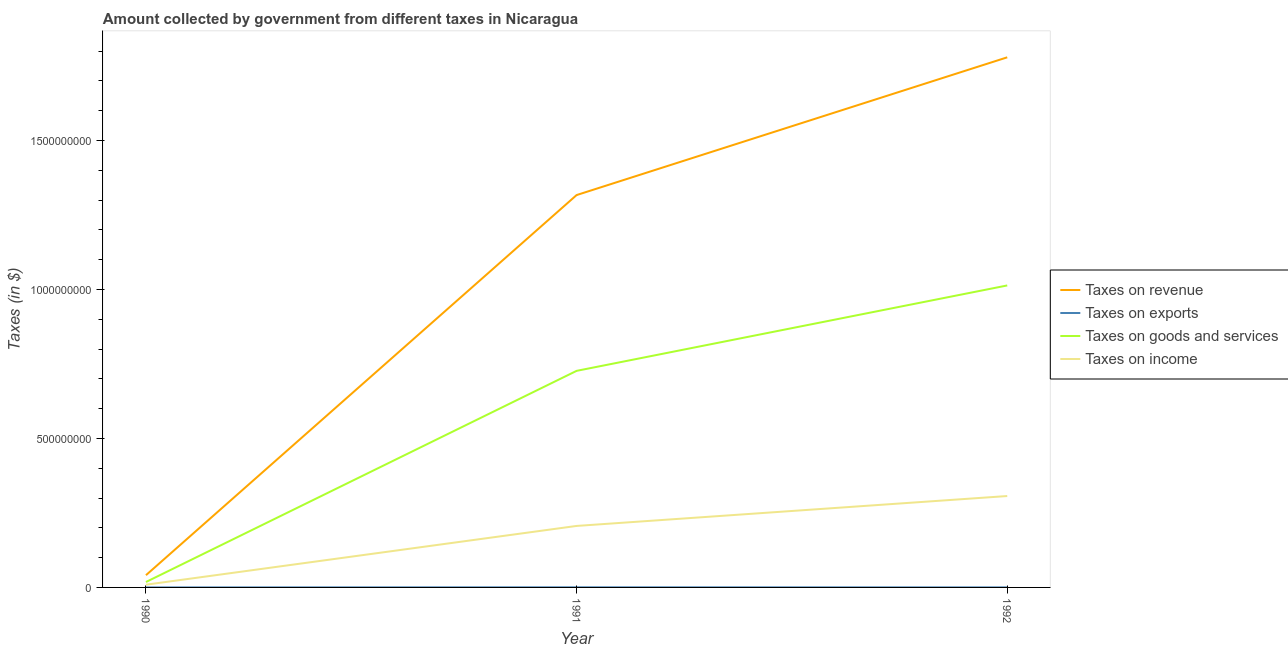What is the amount collected as tax on goods in 1991?
Your answer should be very brief. 7.27e+08. Across all years, what is the maximum amount collected as tax on goods?
Provide a short and direct response. 1.01e+09. Across all years, what is the minimum amount collected as tax on goods?
Your response must be concise. 1.82e+07. In which year was the amount collected as tax on revenue maximum?
Keep it short and to the point. 1992. In which year was the amount collected as tax on goods minimum?
Your answer should be very brief. 1990. What is the total amount collected as tax on goods in the graph?
Provide a short and direct response. 1.76e+09. What is the difference between the amount collected as tax on goods in 1990 and that in 1992?
Offer a terse response. -9.95e+08. What is the difference between the amount collected as tax on goods in 1992 and the amount collected as tax on revenue in 1991?
Offer a very short reply. -3.03e+08. What is the average amount collected as tax on income per year?
Offer a terse response. 1.74e+08. In the year 1990, what is the difference between the amount collected as tax on exports and amount collected as tax on revenue?
Provide a succinct answer. -4.11e+07. In how many years, is the amount collected as tax on revenue greater than 1700000000 $?
Offer a very short reply. 1. What is the ratio of the amount collected as tax on revenue in 1991 to that in 1992?
Your response must be concise. 0.74. Is the difference between the amount collected as tax on revenue in 1990 and 1991 greater than the difference between the amount collected as tax on exports in 1990 and 1991?
Offer a terse response. No. What is the difference between the highest and the second highest amount collected as tax on revenue?
Provide a short and direct response. 4.62e+08. What is the difference between the highest and the lowest amount collected as tax on revenue?
Make the answer very short. 1.74e+09. In how many years, is the amount collected as tax on revenue greater than the average amount collected as tax on revenue taken over all years?
Provide a short and direct response. 2. Is the sum of the amount collected as tax on exports in 1990 and 1991 greater than the maximum amount collected as tax on income across all years?
Make the answer very short. No. Is it the case that in every year, the sum of the amount collected as tax on revenue and amount collected as tax on exports is greater than the amount collected as tax on goods?
Your response must be concise. Yes. How many lines are there?
Keep it short and to the point. 4. What is the difference between two consecutive major ticks on the Y-axis?
Keep it short and to the point. 5.00e+08. Are the values on the major ticks of Y-axis written in scientific E-notation?
Offer a terse response. No. Does the graph contain grids?
Make the answer very short. No. How many legend labels are there?
Your answer should be compact. 4. What is the title of the graph?
Provide a short and direct response. Amount collected by government from different taxes in Nicaragua. What is the label or title of the Y-axis?
Provide a short and direct response. Taxes (in $). What is the Taxes (in $) of Taxes on revenue in 1990?
Your response must be concise. 4.11e+07. What is the Taxes (in $) in Taxes on exports in 1990?
Your response must be concise. 7000. What is the Taxes (in $) in Taxes on goods and services in 1990?
Keep it short and to the point. 1.82e+07. What is the Taxes (in $) in Taxes on income in 1990?
Your answer should be very brief. 9.16e+06. What is the Taxes (in $) of Taxes on revenue in 1991?
Offer a very short reply. 1.32e+09. What is the Taxes (in $) of Taxes on exports in 1991?
Give a very brief answer. 3.60e+05. What is the Taxes (in $) in Taxes on goods and services in 1991?
Provide a short and direct response. 7.27e+08. What is the Taxes (in $) in Taxes on income in 1991?
Ensure brevity in your answer.  2.06e+08. What is the Taxes (in $) in Taxes on revenue in 1992?
Keep it short and to the point. 1.78e+09. What is the Taxes (in $) of Taxes on exports in 1992?
Offer a very short reply. 1.00e+05. What is the Taxes (in $) in Taxes on goods and services in 1992?
Your answer should be very brief. 1.01e+09. What is the Taxes (in $) in Taxes on income in 1992?
Provide a succinct answer. 3.07e+08. Across all years, what is the maximum Taxes (in $) in Taxes on revenue?
Ensure brevity in your answer.  1.78e+09. Across all years, what is the maximum Taxes (in $) of Taxes on exports?
Provide a succinct answer. 3.60e+05. Across all years, what is the maximum Taxes (in $) in Taxes on goods and services?
Offer a very short reply. 1.01e+09. Across all years, what is the maximum Taxes (in $) in Taxes on income?
Ensure brevity in your answer.  3.07e+08. Across all years, what is the minimum Taxes (in $) in Taxes on revenue?
Ensure brevity in your answer.  4.11e+07. Across all years, what is the minimum Taxes (in $) in Taxes on exports?
Your response must be concise. 7000. Across all years, what is the minimum Taxes (in $) of Taxes on goods and services?
Your answer should be compact. 1.82e+07. Across all years, what is the minimum Taxes (in $) in Taxes on income?
Provide a short and direct response. 9.16e+06. What is the total Taxes (in $) of Taxes on revenue in the graph?
Provide a short and direct response. 3.14e+09. What is the total Taxes (in $) of Taxes on exports in the graph?
Your response must be concise. 4.67e+05. What is the total Taxes (in $) in Taxes on goods and services in the graph?
Your answer should be compact. 1.76e+09. What is the total Taxes (in $) of Taxes on income in the graph?
Your answer should be compact. 5.22e+08. What is the difference between the Taxes (in $) in Taxes on revenue in 1990 and that in 1991?
Ensure brevity in your answer.  -1.28e+09. What is the difference between the Taxes (in $) of Taxes on exports in 1990 and that in 1991?
Your answer should be compact. -3.53e+05. What is the difference between the Taxes (in $) in Taxes on goods and services in 1990 and that in 1991?
Ensure brevity in your answer.  -7.09e+08. What is the difference between the Taxes (in $) of Taxes on income in 1990 and that in 1991?
Ensure brevity in your answer.  -1.97e+08. What is the difference between the Taxes (in $) of Taxes on revenue in 1990 and that in 1992?
Your answer should be very brief. -1.74e+09. What is the difference between the Taxes (in $) of Taxes on exports in 1990 and that in 1992?
Your answer should be compact. -9.30e+04. What is the difference between the Taxes (in $) in Taxes on goods and services in 1990 and that in 1992?
Provide a succinct answer. -9.95e+08. What is the difference between the Taxes (in $) of Taxes on income in 1990 and that in 1992?
Ensure brevity in your answer.  -2.98e+08. What is the difference between the Taxes (in $) of Taxes on revenue in 1991 and that in 1992?
Provide a succinct answer. -4.62e+08. What is the difference between the Taxes (in $) of Taxes on goods and services in 1991 and that in 1992?
Your answer should be very brief. -2.87e+08. What is the difference between the Taxes (in $) of Taxes on income in 1991 and that in 1992?
Provide a succinct answer. -1.00e+08. What is the difference between the Taxes (in $) in Taxes on revenue in 1990 and the Taxes (in $) in Taxes on exports in 1991?
Provide a succinct answer. 4.07e+07. What is the difference between the Taxes (in $) of Taxes on revenue in 1990 and the Taxes (in $) of Taxes on goods and services in 1991?
Make the answer very short. -6.86e+08. What is the difference between the Taxes (in $) in Taxes on revenue in 1990 and the Taxes (in $) in Taxes on income in 1991?
Offer a terse response. -1.65e+08. What is the difference between the Taxes (in $) of Taxes on exports in 1990 and the Taxes (in $) of Taxes on goods and services in 1991?
Offer a very short reply. -7.27e+08. What is the difference between the Taxes (in $) of Taxes on exports in 1990 and the Taxes (in $) of Taxes on income in 1991?
Offer a very short reply. -2.06e+08. What is the difference between the Taxes (in $) in Taxes on goods and services in 1990 and the Taxes (in $) in Taxes on income in 1991?
Ensure brevity in your answer.  -1.88e+08. What is the difference between the Taxes (in $) in Taxes on revenue in 1990 and the Taxes (in $) in Taxes on exports in 1992?
Keep it short and to the point. 4.10e+07. What is the difference between the Taxes (in $) of Taxes on revenue in 1990 and the Taxes (in $) of Taxes on goods and services in 1992?
Ensure brevity in your answer.  -9.73e+08. What is the difference between the Taxes (in $) in Taxes on revenue in 1990 and the Taxes (in $) in Taxes on income in 1992?
Give a very brief answer. -2.66e+08. What is the difference between the Taxes (in $) of Taxes on exports in 1990 and the Taxes (in $) of Taxes on goods and services in 1992?
Offer a terse response. -1.01e+09. What is the difference between the Taxes (in $) of Taxes on exports in 1990 and the Taxes (in $) of Taxes on income in 1992?
Provide a short and direct response. -3.07e+08. What is the difference between the Taxes (in $) in Taxes on goods and services in 1990 and the Taxes (in $) in Taxes on income in 1992?
Keep it short and to the point. -2.89e+08. What is the difference between the Taxes (in $) in Taxes on revenue in 1991 and the Taxes (in $) in Taxes on exports in 1992?
Give a very brief answer. 1.32e+09. What is the difference between the Taxes (in $) of Taxes on revenue in 1991 and the Taxes (in $) of Taxes on goods and services in 1992?
Your answer should be compact. 3.03e+08. What is the difference between the Taxes (in $) in Taxes on revenue in 1991 and the Taxes (in $) in Taxes on income in 1992?
Make the answer very short. 1.01e+09. What is the difference between the Taxes (in $) in Taxes on exports in 1991 and the Taxes (in $) in Taxes on goods and services in 1992?
Give a very brief answer. -1.01e+09. What is the difference between the Taxes (in $) of Taxes on exports in 1991 and the Taxes (in $) of Taxes on income in 1992?
Provide a succinct answer. -3.06e+08. What is the difference between the Taxes (in $) of Taxes on goods and services in 1991 and the Taxes (in $) of Taxes on income in 1992?
Ensure brevity in your answer.  4.20e+08. What is the average Taxes (in $) of Taxes on revenue per year?
Your answer should be compact. 1.05e+09. What is the average Taxes (in $) in Taxes on exports per year?
Offer a very short reply. 1.56e+05. What is the average Taxes (in $) in Taxes on goods and services per year?
Your answer should be very brief. 5.86e+08. What is the average Taxes (in $) of Taxes on income per year?
Keep it short and to the point. 1.74e+08. In the year 1990, what is the difference between the Taxes (in $) in Taxes on revenue and Taxes (in $) in Taxes on exports?
Keep it short and to the point. 4.11e+07. In the year 1990, what is the difference between the Taxes (in $) of Taxes on revenue and Taxes (in $) of Taxes on goods and services?
Offer a very short reply. 2.29e+07. In the year 1990, what is the difference between the Taxes (in $) of Taxes on revenue and Taxes (in $) of Taxes on income?
Offer a very short reply. 3.19e+07. In the year 1990, what is the difference between the Taxes (in $) of Taxes on exports and Taxes (in $) of Taxes on goods and services?
Offer a very short reply. -1.82e+07. In the year 1990, what is the difference between the Taxes (in $) in Taxes on exports and Taxes (in $) in Taxes on income?
Provide a succinct answer. -9.15e+06. In the year 1990, what is the difference between the Taxes (in $) of Taxes on goods and services and Taxes (in $) of Taxes on income?
Offer a very short reply. 9.02e+06. In the year 1991, what is the difference between the Taxes (in $) of Taxes on revenue and Taxes (in $) of Taxes on exports?
Ensure brevity in your answer.  1.32e+09. In the year 1991, what is the difference between the Taxes (in $) of Taxes on revenue and Taxes (in $) of Taxes on goods and services?
Provide a succinct answer. 5.90e+08. In the year 1991, what is the difference between the Taxes (in $) in Taxes on revenue and Taxes (in $) in Taxes on income?
Offer a very short reply. 1.11e+09. In the year 1991, what is the difference between the Taxes (in $) in Taxes on exports and Taxes (in $) in Taxes on goods and services?
Make the answer very short. -7.27e+08. In the year 1991, what is the difference between the Taxes (in $) in Taxes on exports and Taxes (in $) in Taxes on income?
Provide a succinct answer. -2.06e+08. In the year 1991, what is the difference between the Taxes (in $) in Taxes on goods and services and Taxes (in $) in Taxes on income?
Offer a very short reply. 5.21e+08. In the year 1992, what is the difference between the Taxes (in $) in Taxes on revenue and Taxes (in $) in Taxes on exports?
Ensure brevity in your answer.  1.78e+09. In the year 1992, what is the difference between the Taxes (in $) in Taxes on revenue and Taxes (in $) in Taxes on goods and services?
Make the answer very short. 7.66e+08. In the year 1992, what is the difference between the Taxes (in $) in Taxes on revenue and Taxes (in $) in Taxes on income?
Ensure brevity in your answer.  1.47e+09. In the year 1992, what is the difference between the Taxes (in $) in Taxes on exports and Taxes (in $) in Taxes on goods and services?
Your response must be concise. -1.01e+09. In the year 1992, what is the difference between the Taxes (in $) of Taxes on exports and Taxes (in $) of Taxes on income?
Provide a succinct answer. -3.07e+08. In the year 1992, what is the difference between the Taxes (in $) in Taxes on goods and services and Taxes (in $) in Taxes on income?
Ensure brevity in your answer.  7.07e+08. What is the ratio of the Taxes (in $) in Taxes on revenue in 1990 to that in 1991?
Offer a terse response. 0.03. What is the ratio of the Taxes (in $) in Taxes on exports in 1990 to that in 1991?
Your answer should be compact. 0.02. What is the ratio of the Taxes (in $) of Taxes on goods and services in 1990 to that in 1991?
Your response must be concise. 0.03. What is the ratio of the Taxes (in $) in Taxes on income in 1990 to that in 1991?
Your answer should be very brief. 0.04. What is the ratio of the Taxes (in $) in Taxes on revenue in 1990 to that in 1992?
Ensure brevity in your answer.  0.02. What is the ratio of the Taxes (in $) of Taxes on exports in 1990 to that in 1992?
Your answer should be very brief. 0.07. What is the ratio of the Taxes (in $) of Taxes on goods and services in 1990 to that in 1992?
Provide a short and direct response. 0.02. What is the ratio of the Taxes (in $) of Taxes on income in 1990 to that in 1992?
Your answer should be very brief. 0.03. What is the ratio of the Taxes (in $) in Taxes on revenue in 1991 to that in 1992?
Provide a succinct answer. 0.74. What is the ratio of the Taxes (in $) of Taxes on exports in 1991 to that in 1992?
Make the answer very short. 3.6. What is the ratio of the Taxes (in $) of Taxes on goods and services in 1991 to that in 1992?
Offer a terse response. 0.72. What is the ratio of the Taxes (in $) of Taxes on income in 1991 to that in 1992?
Keep it short and to the point. 0.67. What is the difference between the highest and the second highest Taxes (in $) of Taxes on revenue?
Make the answer very short. 4.62e+08. What is the difference between the highest and the second highest Taxes (in $) of Taxes on goods and services?
Your response must be concise. 2.87e+08. What is the difference between the highest and the second highest Taxes (in $) in Taxes on income?
Offer a very short reply. 1.00e+08. What is the difference between the highest and the lowest Taxes (in $) in Taxes on revenue?
Make the answer very short. 1.74e+09. What is the difference between the highest and the lowest Taxes (in $) of Taxes on exports?
Keep it short and to the point. 3.53e+05. What is the difference between the highest and the lowest Taxes (in $) of Taxes on goods and services?
Give a very brief answer. 9.95e+08. What is the difference between the highest and the lowest Taxes (in $) of Taxes on income?
Ensure brevity in your answer.  2.98e+08. 